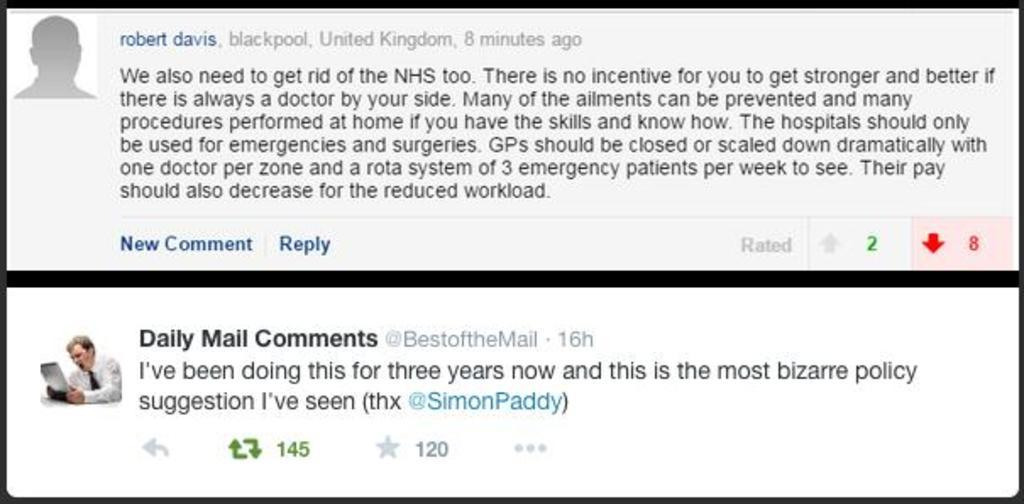What types of elements can be seen in the image? There are symbols, text, numbers, and an image of a person in the image. What is the person in the image doing? The person is holding an object. Can you describe the object the person is holding? Unfortunately, the image does not provide enough detail to describe the object. What type of slope can be seen in the image? There is no slope present in the image. What type of quartz is visible in the image? There is no quartz present in the image. 